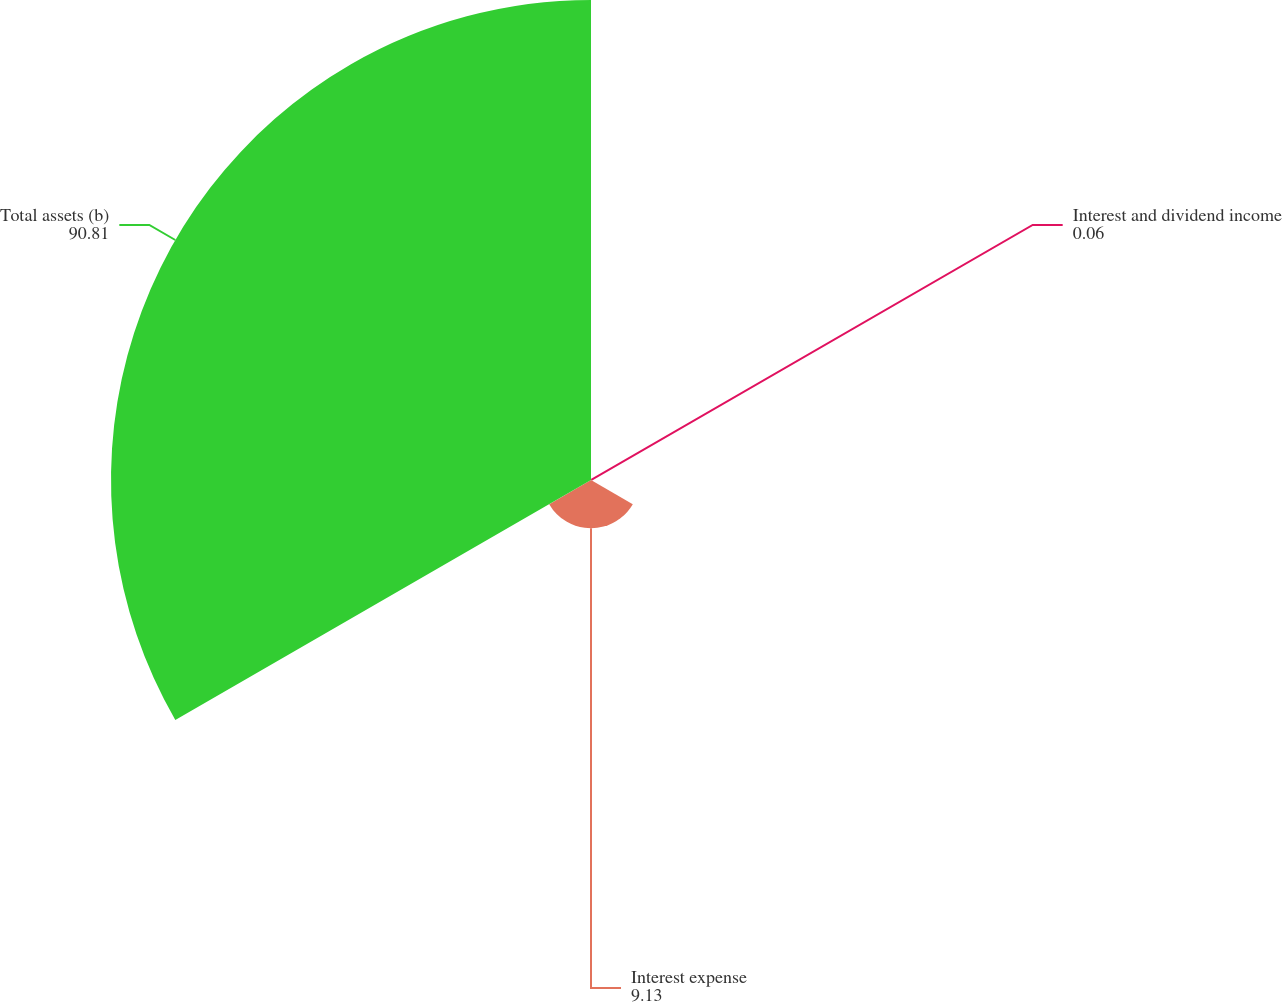Convert chart. <chart><loc_0><loc_0><loc_500><loc_500><pie_chart><fcel>Interest and dividend income<fcel>Interest expense<fcel>Total assets (b)<nl><fcel>0.06%<fcel>9.13%<fcel>90.81%<nl></chart> 